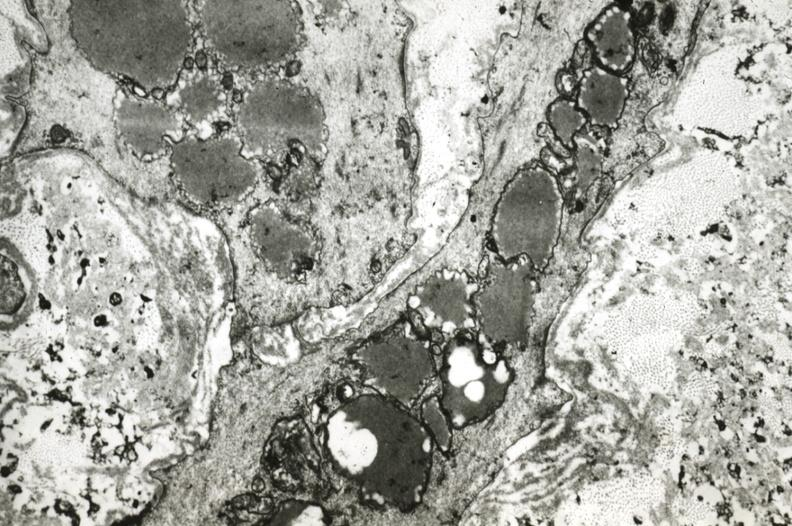s coronary artery present?
Answer the question using a single word or phrase. Yes 